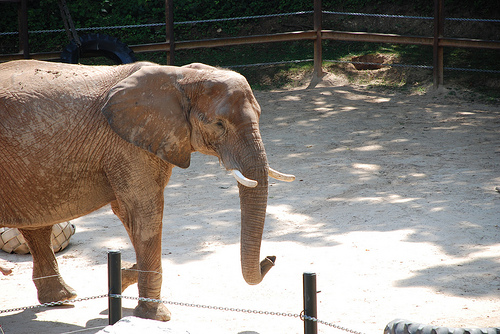<image>
Is the elephant in front of the tree? No. The elephant is not in front of the tree. The spatial positioning shows a different relationship between these objects. 